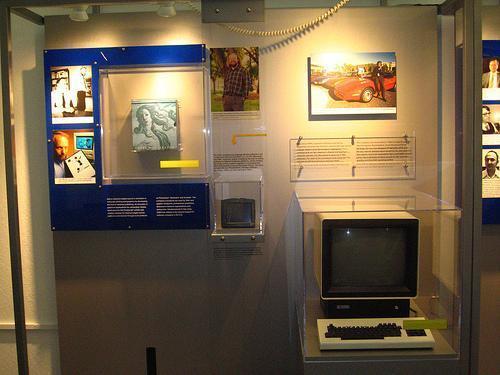How many boxes on the wall contain electronics?
Give a very brief answer. 2. 